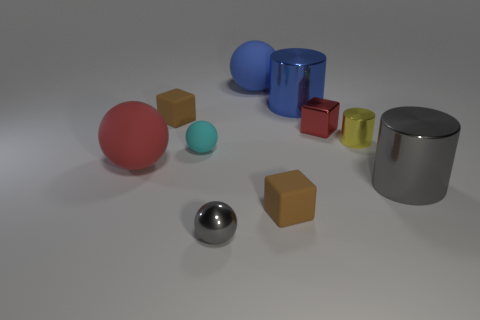Subtract all large gray shiny cylinders. How many cylinders are left? 2 Subtract all cyan spheres. How many brown blocks are left? 2 Subtract all yellow cylinders. How many cylinders are left? 2 Subtract 1 balls. How many balls are left? 3 Add 4 small yellow objects. How many small yellow objects exist? 5 Subtract 1 red balls. How many objects are left? 9 Subtract all cylinders. How many objects are left? 7 Subtract all green cubes. Subtract all red cylinders. How many cubes are left? 3 Subtract all large yellow blocks. Subtract all brown blocks. How many objects are left? 8 Add 2 rubber spheres. How many rubber spheres are left? 5 